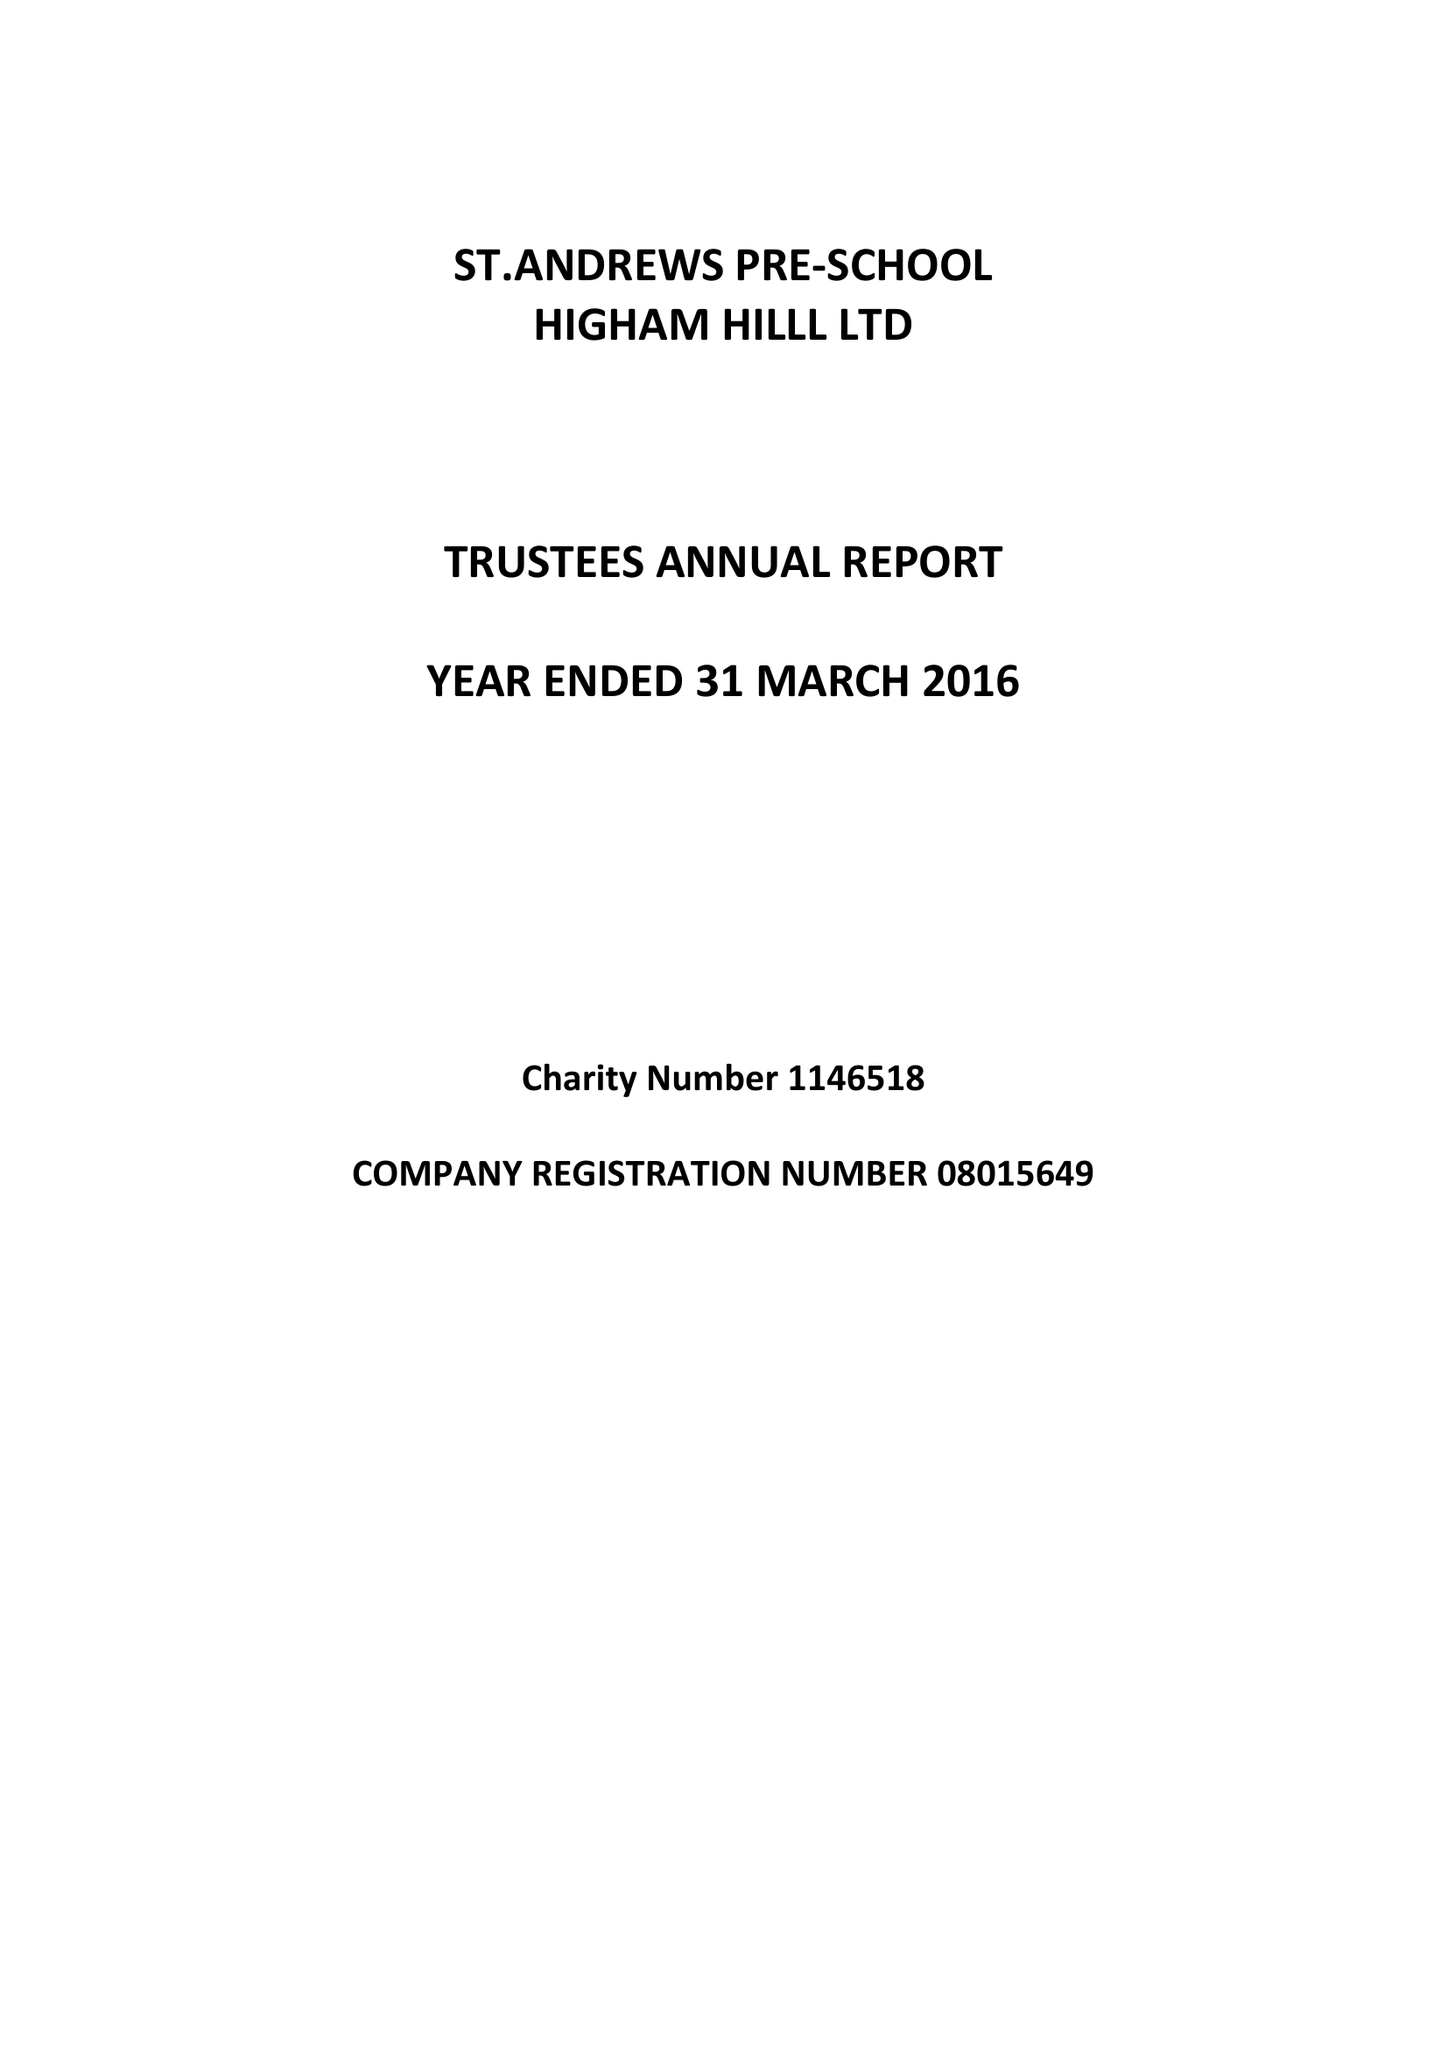What is the value for the report_date?
Answer the question using a single word or phrase. 2016-03-31 